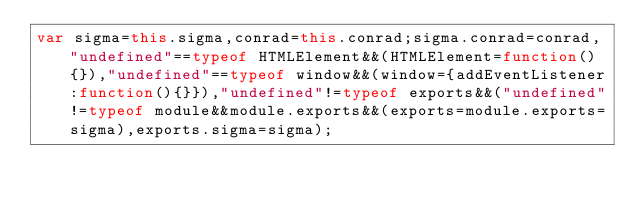Convert code to text. <code><loc_0><loc_0><loc_500><loc_500><_JavaScript_>var sigma=this.sigma,conrad=this.conrad;sigma.conrad=conrad,"undefined"==typeof HTMLElement&&(HTMLElement=function(){}),"undefined"==typeof window&&(window={addEventListener:function(){}}),"undefined"!=typeof exports&&("undefined"!=typeof module&&module.exports&&(exports=module.exports=sigma),exports.sigma=sigma);</code> 